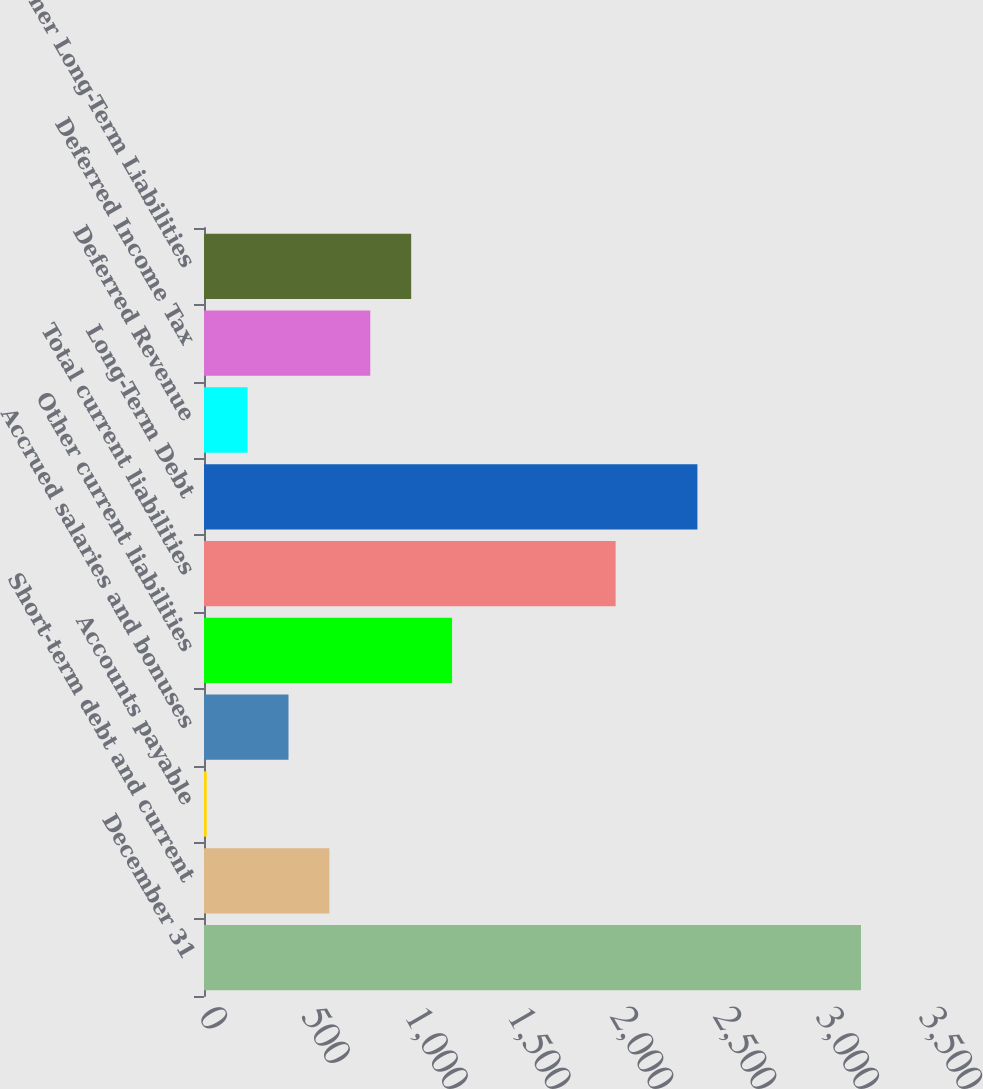<chart> <loc_0><loc_0><loc_500><loc_500><bar_chart><fcel>December 31<fcel>Short-term debt and current<fcel>Accounts payable<fcel>Accrued salaries and bonuses<fcel>Other current liabilities<fcel>Total current liabilities<fcel>Long-Term Debt<fcel>Deferred Revenue<fcel>Deferred Income Tax<fcel>Other Long-Term Liabilities<nl><fcel>3193.68<fcel>609.54<fcel>13.2<fcel>410.76<fcel>1205.88<fcel>2001<fcel>2398.56<fcel>211.98<fcel>808.32<fcel>1007.1<nl></chart> 